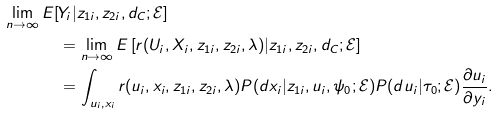Convert formula to latex. <formula><loc_0><loc_0><loc_500><loc_500>\lim _ { n \rightarrow \infty } E [ & Y _ { i } | z _ { 1 i } , z _ { 2 i } , d _ { C } ; \mathcal { E } ] \\ & = \lim _ { n \rightarrow \infty } E \left [ r ( U _ { i } , X _ { i } , z _ { 1 i } , z _ { 2 i } , \lambda ) | z _ { 1 i } , z _ { 2 i } , d _ { C } ; \mathcal { E } \right ] \\ & = \int _ { u _ { i } , x _ { i } } r ( u _ { i } , x _ { i } , z _ { 1 i } , z _ { 2 i } , \lambda ) P ( d x _ { i } | z _ { 1 i } , u _ { i } , \psi _ { 0 } ; \mathcal { E } ) P ( d u _ { i } | \tau _ { 0 } ; \mathcal { E } ) \frac { \partial u _ { i } } { \partial y _ { i } } .</formula> 